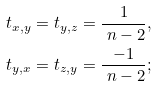Convert formula to latex. <formula><loc_0><loc_0><loc_500><loc_500>t _ { x , y } = t _ { y , z } & = \frac { 1 } { \ n - 2 } , \\ t _ { y , x } = t _ { z , y } & = \frac { - 1 } { \ n - 2 } ;</formula> 